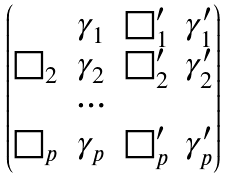Convert formula to latex. <formula><loc_0><loc_0><loc_500><loc_500>\begin{pmatrix} & \gamma _ { 1 } & \square ^ { \prime } _ { 1 } & \gamma ^ { \prime } _ { 1 } \\ \square _ { 2 } & \gamma _ { 2 } & \square ^ { \prime } _ { 2 } & \gamma ^ { \prime } _ { 2 } \\ & \cdots \\ \square _ { p } & \gamma _ { p } & \square ^ { \prime } _ { p } & \gamma ^ { \prime } _ { p } \\ \end{pmatrix}</formula> 